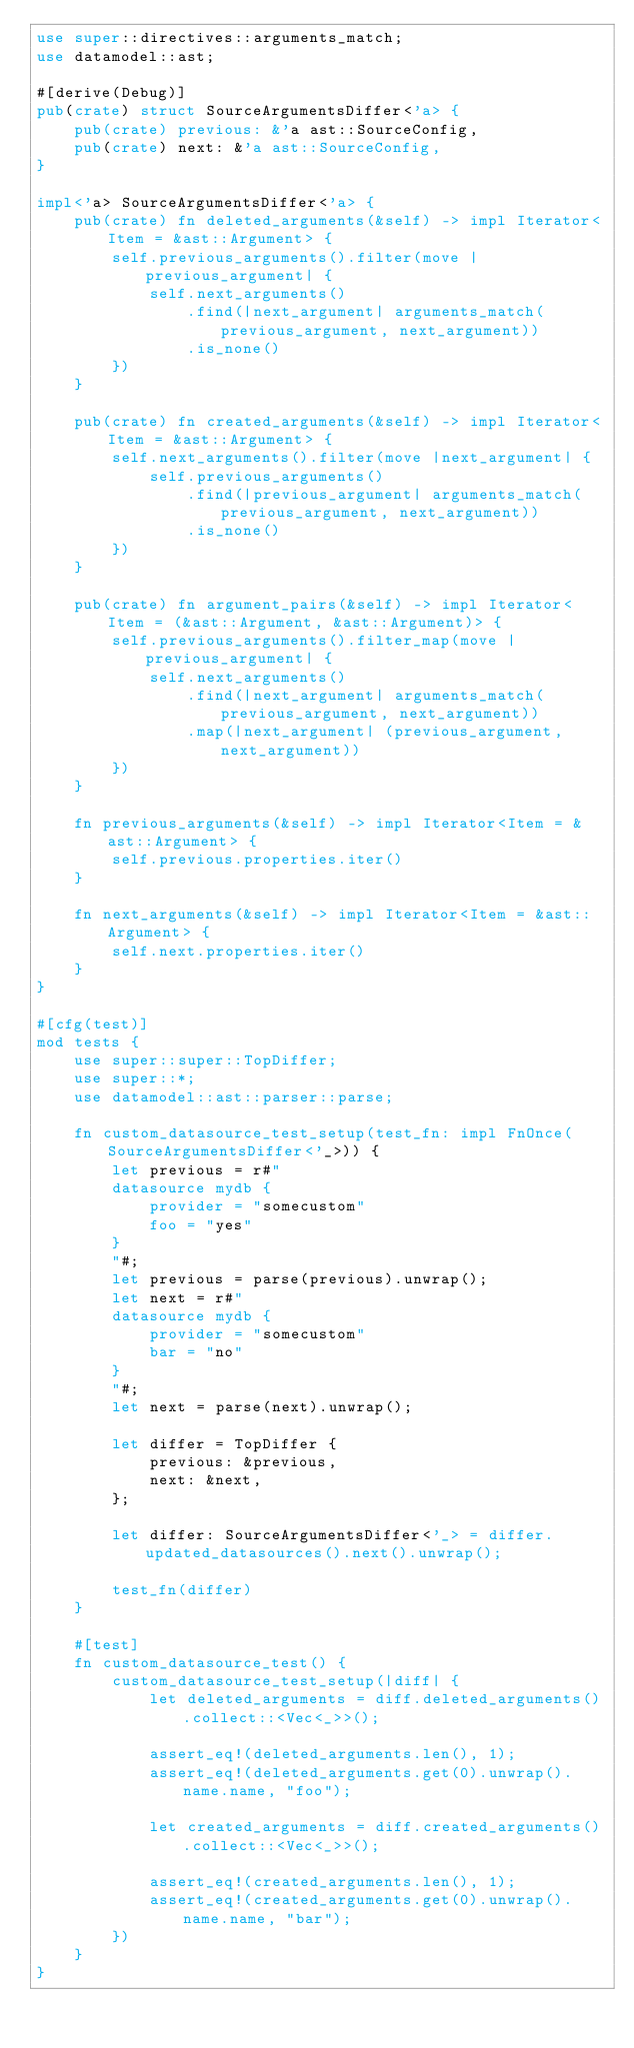Convert code to text. <code><loc_0><loc_0><loc_500><loc_500><_Rust_>use super::directives::arguments_match;
use datamodel::ast;

#[derive(Debug)]
pub(crate) struct SourceArgumentsDiffer<'a> {
    pub(crate) previous: &'a ast::SourceConfig,
    pub(crate) next: &'a ast::SourceConfig,
}

impl<'a> SourceArgumentsDiffer<'a> {
    pub(crate) fn deleted_arguments(&self) -> impl Iterator<Item = &ast::Argument> {
        self.previous_arguments().filter(move |previous_argument| {
            self.next_arguments()
                .find(|next_argument| arguments_match(previous_argument, next_argument))
                .is_none()
        })
    }

    pub(crate) fn created_arguments(&self) -> impl Iterator<Item = &ast::Argument> {
        self.next_arguments().filter(move |next_argument| {
            self.previous_arguments()
                .find(|previous_argument| arguments_match(previous_argument, next_argument))
                .is_none()
        })
    }

    pub(crate) fn argument_pairs(&self) -> impl Iterator<Item = (&ast::Argument, &ast::Argument)> {
        self.previous_arguments().filter_map(move |previous_argument| {
            self.next_arguments()
                .find(|next_argument| arguments_match(previous_argument, next_argument))
                .map(|next_argument| (previous_argument, next_argument))
        })
    }

    fn previous_arguments(&self) -> impl Iterator<Item = &ast::Argument> {
        self.previous.properties.iter()
    }

    fn next_arguments(&self) -> impl Iterator<Item = &ast::Argument> {
        self.next.properties.iter()
    }
}

#[cfg(test)]
mod tests {
    use super::super::TopDiffer;
    use super::*;
    use datamodel::ast::parser::parse;

    fn custom_datasource_test_setup(test_fn: impl FnOnce(SourceArgumentsDiffer<'_>)) {
        let previous = r#"
        datasource mydb {
            provider = "somecustom"
            foo = "yes"
        }
        "#;
        let previous = parse(previous).unwrap();
        let next = r#"
        datasource mydb {
            provider = "somecustom"
            bar = "no"
        }
        "#;
        let next = parse(next).unwrap();

        let differ = TopDiffer {
            previous: &previous,
            next: &next,
        };

        let differ: SourceArgumentsDiffer<'_> = differ.updated_datasources().next().unwrap();

        test_fn(differ)
    }

    #[test]
    fn custom_datasource_test() {
        custom_datasource_test_setup(|diff| {
            let deleted_arguments = diff.deleted_arguments().collect::<Vec<_>>();

            assert_eq!(deleted_arguments.len(), 1);
            assert_eq!(deleted_arguments.get(0).unwrap().name.name, "foo");

            let created_arguments = diff.created_arguments().collect::<Vec<_>>();

            assert_eq!(created_arguments.len(), 1);
            assert_eq!(created_arguments.get(0).unwrap().name.name, "bar");
        })
    }
}
</code> 